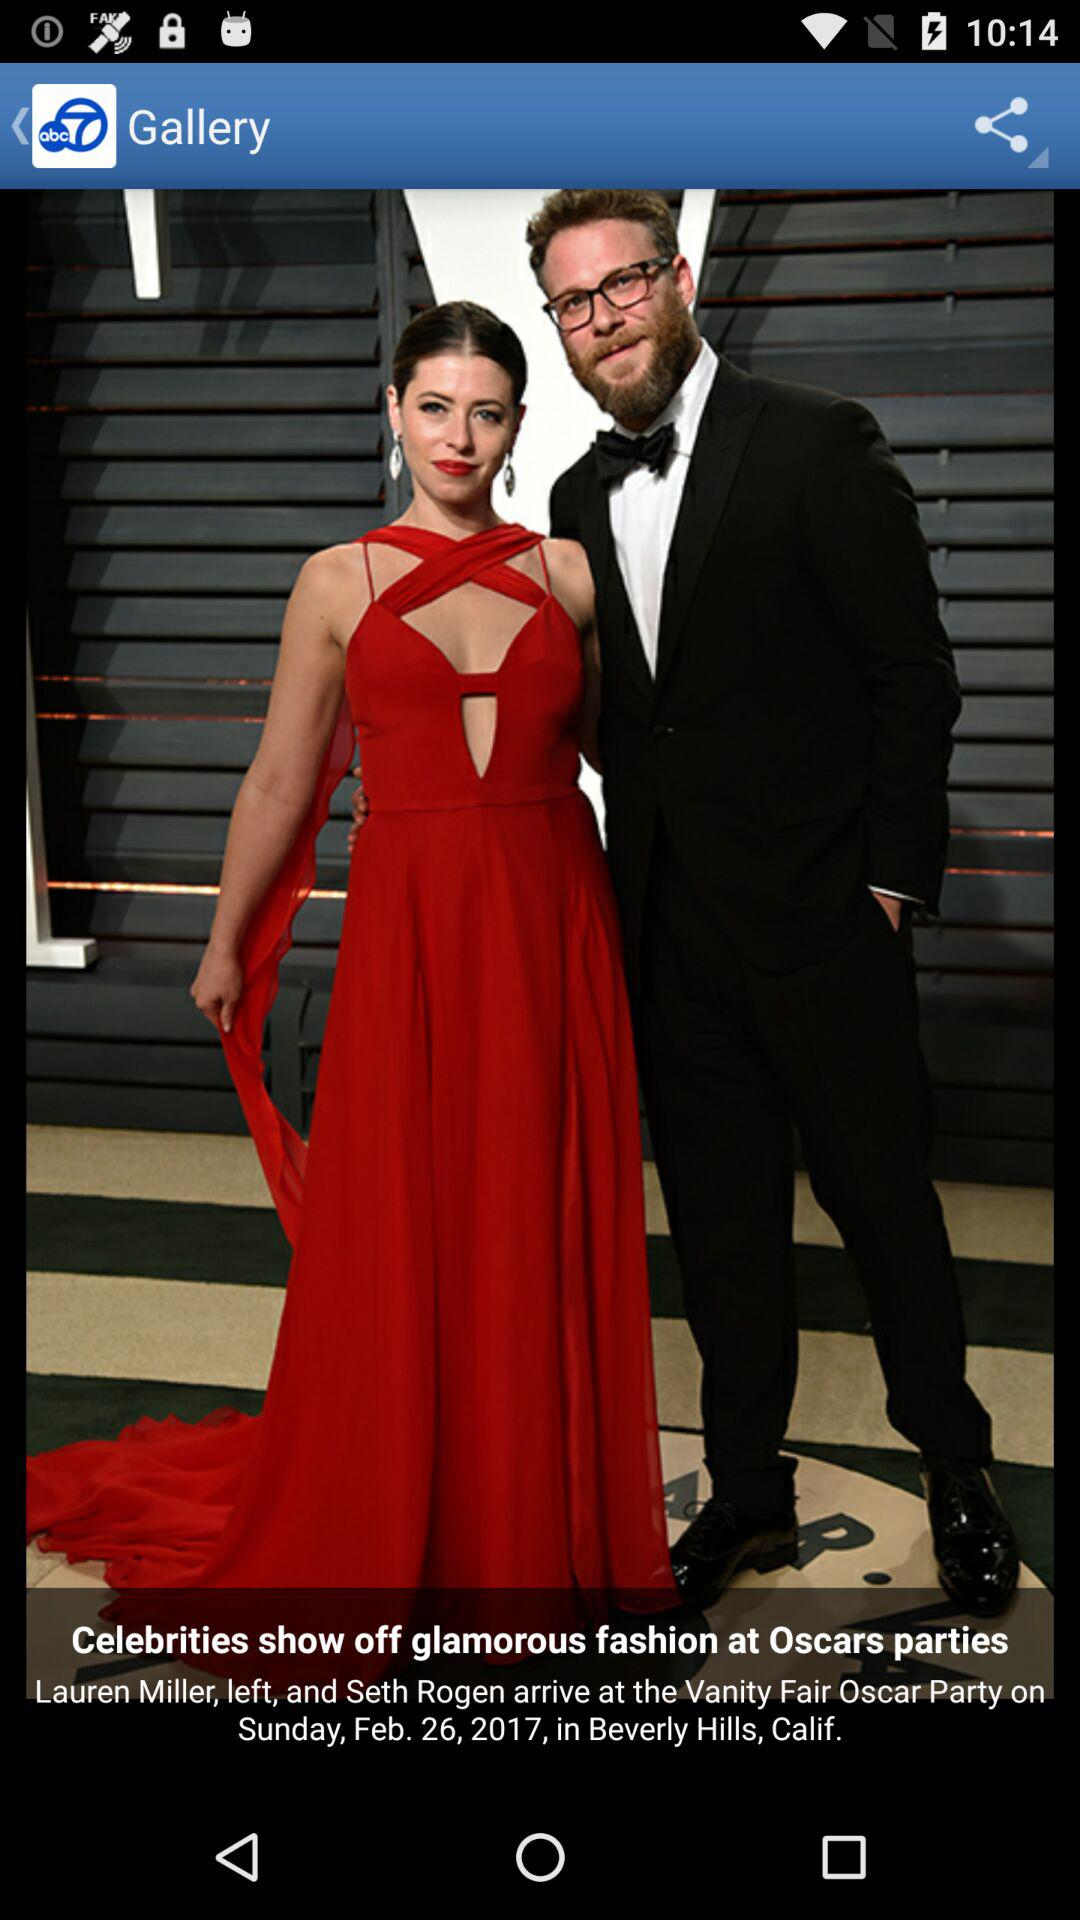When was the "Vanity Fair Oscar Party" held? The "Vanity Fair Oscar Party" was held on Sunday, February 26, 2017. 